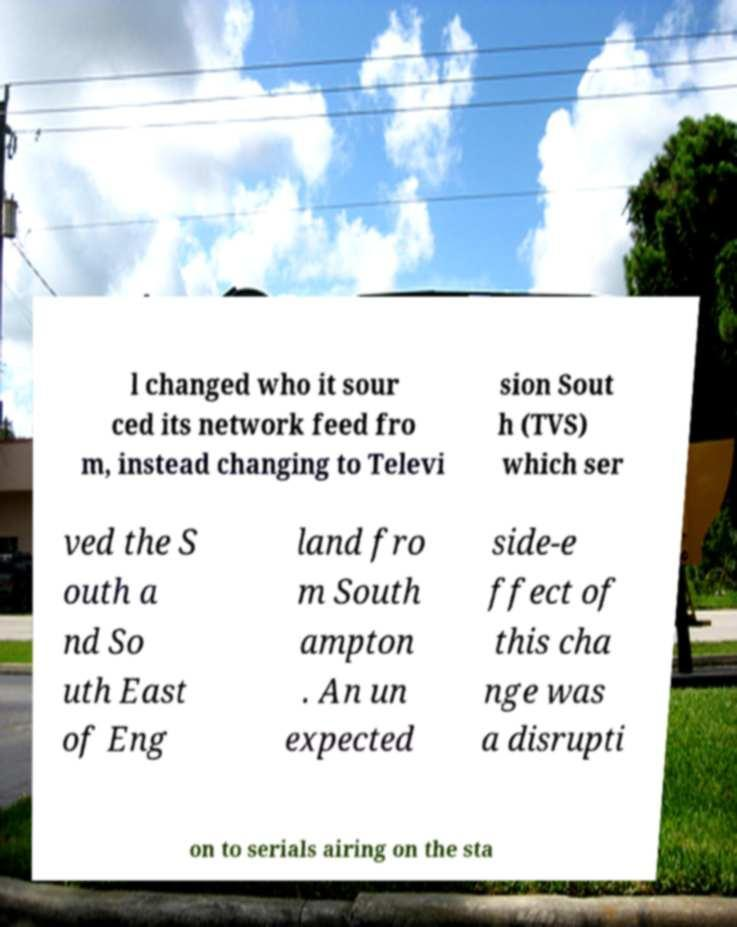Could you assist in decoding the text presented in this image and type it out clearly? l changed who it sour ced its network feed fro m, instead changing to Televi sion Sout h (TVS) which ser ved the S outh a nd So uth East of Eng land fro m South ampton . An un expected side-e ffect of this cha nge was a disrupti on to serials airing on the sta 